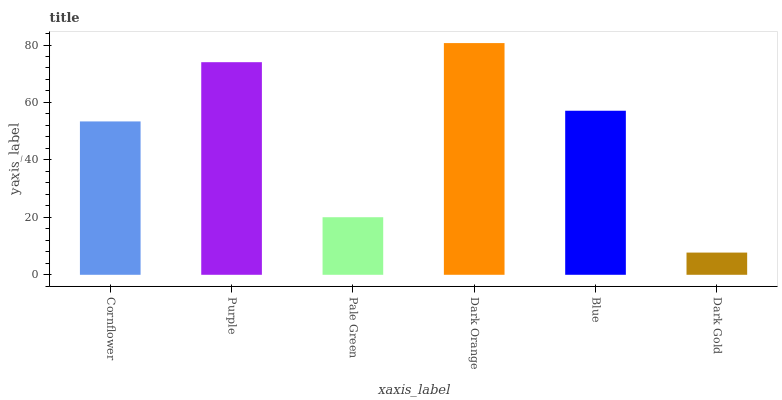Is Dark Gold the minimum?
Answer yes or no. Yes. Is Dark Orange the maximum?
Answer yes or no. Yes. Is Purple the minimum?
Answer yes or no. No. Is Purple the maximum?
Answer yes or no. No. Is Purple greater than Cornflower?
Answer yes or no. Yes. Is Cornflower less than Purple?
Answer yes or no. Yes. Is Cornflower greater than Purple?
Answer yes or no. No. Is Purple less than Cornflower?
Answer yes or no. No. Is Blue the high median?
Answer yes or no. Yes. Is Cornflower the low median?
Answer yes or no. Yes. Is Purple the high median?
Answer yes or no. No. Is Dark Gold the low median?
Answer yes or no. No. 